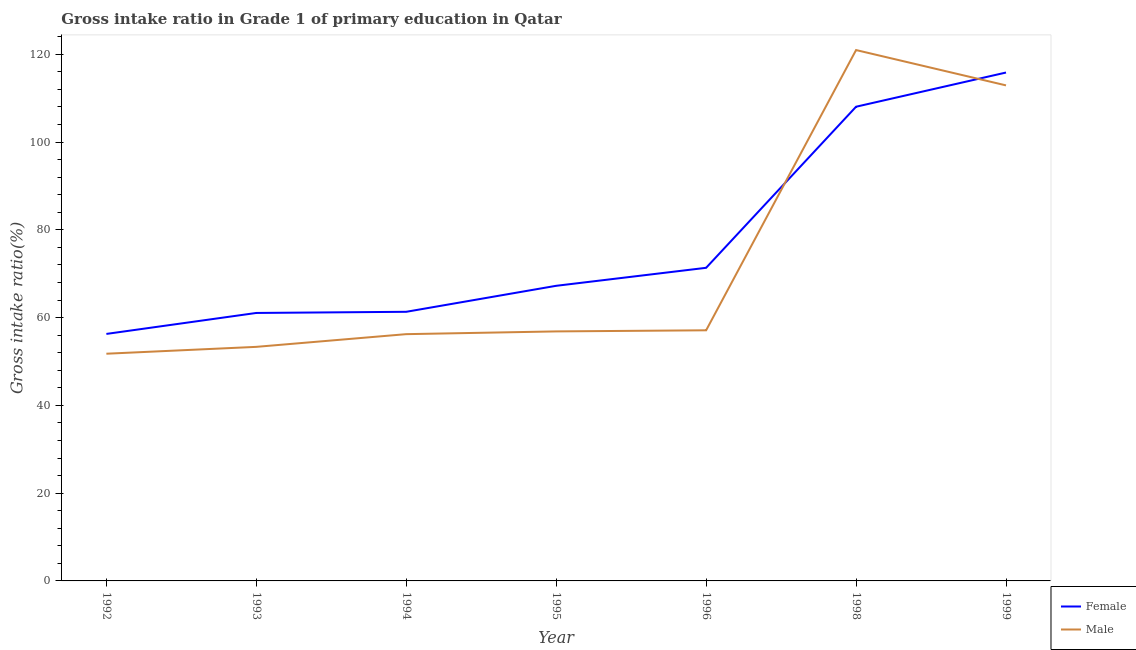How many different coloured lines are there?
Your answer should be very brief. 2. What is the gross intake ratio(female) in 1999?
Ensure brevity in your answer.  115.83. Across all years, what is the maximum gross intake ratio(male)?
Offer a terse response. 120.95. Across all years, what is the minimum gross intake ratio(male)?
Your response must be concise. 51.77. In which year was the gross intake ratio(female) minimum?
Your answer should be very brief. 1992. What is the total gross intake ratio(male) in the graph?
Offer a very short reply. 509.13. What is the difference between the gross intake ratio(female) in 1998 and that in 1999?
Provide a succinct answer. -7.79. What is the difference between the gross intake ratio(male) in 1996 and the gross intake ratio(female) in 1993?
Your response must be concise. -3.95. What is the average gross intake ratio(male) per year?
Keep it short and to the point. 72.73. In the year 1995, what is the difference between the gross intake ratio(female) and gross intake ratio(male)?
Provide a succinct answer. 10.39. What is the ratio of the gross intake ratio(male) in 1993 to that in 1999?
Offer a very short reply. 0.47. Is the gross intake ratio(female) in 1994 less than that in 1996?
Offer a very short reply. Yes. Is the difference between the gross intake ratio(male) in 1998 and 1999 greater than the difference between the gross intake ratio(female) in 1998 and 1999?
Provide a succinct answer. Yes. What is the difference between the highest and the second highest gross intake ratio(female)?
Give a very brief answer. 7.79. What is the difference between the highest and the lowest gross intake ratio(female)?
Offer a very short reply. 59.55. In how many years, is the gross intake ratio(male) greater than the average gross intake ratio(male) taken over all years?
Provide a short and direct response. 2. Is the gross intake ratio(male) strictly less than the gross intake ratio(female) over the years?
Provide a short and direct response. No. What is the difference between two consecutive major ticks on the Y-axis?
Offer a very short reply. 20. Does the graph contain any zero values?
Ensure brevity in your answer.  No. Does the graph contain grids?
Your answer should be compact. No. How many legend labels are there?
Your answer should be very brief. 2. How are the legend labels stacked?
Give a very brief answer. Vertical. What is the title of the graph?
Ensure brevity in your answer.  Gross intake ratio in Grade 1 of primary education in Qatar. Does "All education staff compensation" appear as one of the legend labels in the graph?
Keep it short and to the point. No. What is the label or title of the Y-axis?
Offer a terse response. Gross intake ratio(%). What is the Gross intake ratio(%) of Female in 1992?
Ensure brevity in your answer.  56.28. What is the Gross intake ratio(%) in Male in 1992?
Make the answer very short. 51.77. What is the Gross intake ratio(%) in Female in 1993?
Keep it short and to the point. 61.06. What is the Gross intake ratio(%) in Male in 1993?
Provide a short and direct response. 53.33. What is the Gross intake ratio(%) in Female in 1994?
Give a very brief answer. 61.32. What is the Gross intake ratio(%) in Male in 1994?
Ensure brevity in your answer.  56.23. What is the Gross intake ratio(%) in Female in 1995?
Provide a short and direct response. 67.24. What is the Gross intake ratio(%) of Male in 1995?
Your response must be concise. 56.85. What is the Gross intake ratio(%) in Female in 1996?
Provide a succinct answer. 71.34. What is the Gross intake ratio(%) in Male in 1996?
Make the answer very short. 57.1. What is the Gross intake ratio(%) of Female in 1998?
Your answer should be very brief. 108.04. What is the Gross intake ratio(%) in Male in 1998?
Provide a succinct answer. 120.95. What is the Gross intake ratio(%) of Female in 1999?
Your response must be concise. 115.83. What is the Gross intake ratio(%) of Male in 1999?
Make the answer very short. 112.9. Across all years, what is the maximum Gross intake ratio(%) in Female?
Ensure brevity in your answer.  115.83. Across all years, what is the maximum Gross intake ratio(%) of Male?
Keep it short and to the point. 120.95. Across all years, what is the minimum Gross intake ratio(%) of Female?
Ensure brevity in your answer.  56.28. Across all years, what is the minimum Gross intake ratio(%) of Male?
Offer a very short reply. 51.77. What is the total Gross intake ratio(%) of Female in the graph?
Your answer should be compact. 541.1. What is the total Gross intake ratio(%) of Male in the graph?
Give a very brief answer. 509.13. What is the difference between the Gross intake ratio(%) of Female in 1992 and that in 1993?
Your response must be concise. -4.78. What is the difference between the Gross intake ratio(%) in Male in 1992 and that in 1993?
Offer a terse response. -1.57. What is the difference between the Gross intake ratio(%) in Female in 1992 and that in 1994?
Your answer should be very brief. -5.04. What is the difference between the Gross intake ratio(%) of Male in 1992 and that in 1994?
Your answer should be very brief. -4.46. What is the difference between the Gross intake ratio(%) of Female in 1992 and that in 1995?
Your answer should be compact. -10.96. What is the difference between the Gross intake ratio(%) of Male in 1992 and that in 1995?
Give a very brief answer. -5.08. What is the difference between the Gross intake ratio(%) of Female in 1992 and that in 1996?
Provide a succinct answer. -15.06. What is the difference between the Gross intake ratio(%) of Male in 1992 and that in 1996?
Make the answer very short. -5.34. What is the difference between the Gross intake ratio(%) of Female in 1992 and that in 1998?
Offer a very short reply. -51.77. What is the difference between the Gross intake ratio(%) of Male in 1992 and that in 1998?
Ensure brevity in your answer.  -69.19. What is the difference between the Gross intake ratio(%) of Female in 1992 and that in 1999?
Ensure brevity in your answer.  -59.55. What is the difference between the Gross intake ratio(%) of Male in 1992 and that in 1999?
Ensure brevity in your answer.  -61.14. What is the difference between the Gross intake ratio(%) in Female in 1993 and that in 1994?
Provide a succinct answer. -0.26. What is the difference between the Gross intake ratio(%) of Male in 1993 and that in 1994?
Your answer should be compact. -2.89. What is the difference between the Gross intake ratio(%) in Female in 1993 and that in 1995?
Offer a very short reply. -6.19. What is the difference between the Gross intake ratio(%) of Male in 1993 and that in 1995?
Give a very brief answer. -3.52. What is the difference between the Gross intake ratio(%) in Female in 1993 and that in 1996?
Your response must be concise. -10.29. What is the difference between the Gross intake ratio(%) of Male in 1993 and that in 1996?
Your answer should be very brief. -3.77. What is the difference between the Gross intake ratio(%) of Female in 1993 and that in 1998?
Keep it short and to the point. -46.99. What is the difference between the Gross intake ratio(%) in Male in 1993 and that in 1998?
Your response must be concise. -67.62. What is the difference between the Gross intake ratio(%) in Female in 1993 and that in 1999?
Offer a very short reply. -54.78. What is the difference between the Gross intake ratio(%) of Male in 1993 and that in 1999?
Offer a terse response. -59.57. What is the difference between the Gross intake ratio(%) of Female in 1994 and that in 1995?
Offer a very short reply. -5.92. What is the difference between the Gross intake ratio(%) of Male in 1994 and that in 1995?
Make the answer very short. -0.62. What is the difference between the Gross intake ratio(%) in Female in 1994 and that in 1996?
Provide a succinct answer. -10.02. What is the difference between the Gross intake ratio(%) of Male in 1994 and that in 1996?
Make the answer very short. -0.88. What is the difference between the Gross intake ratio(%) of Female in 1994 and that in 1998?
Make the answer very short. -46.73. What is the difference between the Gross intake ratio(%) of Male in 1994 and that in 1998?
Give a very brief answer. -64.73. What is the difference between the Gross intake ratio(%) of Female in 1994 and that in 1999?
Offer a terse response. -54.51. What is the difference between the Gross intake ratio(%) in Male in 1994 and that in 1999?
Offer a very short reply. -56.68. What is the difference between the Gross intake ratio(%) in Female in 1995 and that in 1996?
Ensure brevity in your answer.  -4.1. What is the difference between the Gross intake ratio(%) in Male in 1995 and that in 1996?
Your response must be concise. -0.25. What is the difference between the Gross intake ratio(%) in Female in 1995 and that in 1998?
Give a very brief answer. -40.8. What is the difference between the Gross intake ratio(%) of Male in 1995 and that in 1998?
Provide a short and direct response. -64.1. What is the difference between the Gross intake ratio(%) in Female in 1995 and that in 1999?
Ensure brevity in your answer.  -48.59. What is the difference between the Gross intake ratio(%) in Male in 1995 and that in 1999?
Give a very brief answer. -56.06. What is the difference between the Gross intake ratio(%) in Female in 1996 and that in 1998?
Keep it short and to the point. -36.7. What is the difference between the Gross intake ratio(%) of Male in 1996 and that in 1998?
Make the answer very short. -63.85. What is the difference between the Gross intake ratio(%) of Female in 1996 and that in 1999?
Provide a succinct answer. -44.49. What is the difference between the Gross intake ratio(%) of Male in 1996 and that in 1999?
Offer a terse response. -55.8. What is the difference between the Gross intake ratio(%) of Female in 1998 and that in 1999?
Make the answer very short. -7.79. What is the difference between the Gross intake ratio(%) in Male in 1998 and that in 1999?
Give a very brief answer. 8.05. What is the difference between the Gross intake ratio(%) in Female in 1992 and the Gross intake ratio(%) in Male in 1993?
Make the answer very short. 2.95. What is the difference between the Gross intake ratio(%) of Female in 1992 and the Gross intake ratio(%) of Male in 1994?
Ensure brevity in your answer.  0.05. What is the difference between the Gross intake ratio(%) of Female in 1992 and the Gross intake ratio(%) of Male in 1995?
Provide a succinct answer. -0.57. What is the difference between the Gross intake ratio(%) of Female in 1992 and the Gross intake ratio(%) of Male in 1996?
Make the answer very short. -0.83. What is the difference between the Gross intake ratio(%) of Female in 1992 and the Gross intake ratio(%) of Male in 1998?
Ensure brevity in your answer.  -64.68. What is the difference between the Gross intake ratio(%) of Female in 1992 and the Gross intake ratio(%) of Male in 1999?
Your answer should be compact. -56.63. What is the difference between the Gross intake ratio(%) in Female in 1993 and the Gross intake ratio(%) in Male in 1994?
Keep it short and to the point. 4.83. What is the difference between the Gross intake ratio(%) in Female in 1993 and the Gross intake ratio(%) in Male in 1995?
Keep it short and to the point. 4.21. What is the difference between the Gross intake ratio(%) of Female in 1993 and the Gross intake ratio(%) of Male in 1996?
Your answer should be compact. 3.95. What is the difference between the Gross intake ratio(%) in Female in 1993 and the Gross intake ratio(%) in Male in 1998?
Ensure brevity in your answer.  -59.9. What is the difference between the Gross intake ratio(%) in Female in 1993 and the Gross intake ratio(%) in Male in 1999?
Keep it short and to the point. -51.85. What is the difference between the Gross intake ratio(%) of Female in 1994 and the Gross intake ratio(%) of Male in 1995?
Your response must be concise. 4.47. What is the difference between the Gross intake ratio(%) in Female in 1994 and the Gross intake ratio(%) in Male in 1996?
Offer a terse response. 4.21. What is the difference between the Gross intake ratio(%) in Female in 1994 and the Gross intake ratio(%) in Male in 1998?
Your response must be concise. -59.64. What is the difference between the Gross intake ratio(%) of Female in 1994 and the Gross intake ratio(%) of Male in 1999?
Your answer should be compact. -51.59. What is the difference between the Gross intake ratio(%) of Female in 1995 and the Gross intake ratio(%) of Male in 1996?
Give a very brief answer. 10.14. What is the difference between the Gross intake ratio(%) in Female in 1995 and the Gross intake ratio(%) in Male in 1998?
Give a very brief answer. -53.71. What is the difference between the Gross intake ratio(%) of Female in 1995 and the Gross intake ratio(%) of Male in 1999?
Give a very brief answer. -45.66. What is the difference between the Gross intake ratio(%) of Female in 1996 and the Gross intake ratio(%) of Male in 1998?
Offer a very short reply. -49.61. What is the difference between the Gross intake ratio(%) in Female in 1996 and the Gross intake ratio(%) in Male in 1999?
Your response must be concise. -41.56. What is the difference between the Gross intake ratio(%) of Female in 1998 and the Gross intake ratio(%) of Male in 1999?
Offer a very short reply. -4.86. What is the average Gross intake ratio(%) in Female per year?
Your response must be concise. 77.3. What is the average Gross intake ratio(%) in Male per year?
Provide a short and direct response. 72.73. In the year 1992, what is the difference between the Gross intake ratio(%) of Female and Gross intake ratio(%) of Male?
Provide a short and direct response. 4.51. In the year 1993, what is the difference between the Gross intake ratio(%) in Female and Gross intake ratio(%) in Male?
Keep it short and to the point. 7.72. In the year 1994, what is the difference between the Gross intake ratio(%) in Female and Gross intake ratio(%) in Male?
Provide a short and direct response. 5.09. In the year 1995, what is the difference between the Gross intake ratio(%) in Female and Gross intake ratio(%) in Male?
Your answer should be compact. 10.39. In the year 1996, what is the difference between the Gross intake ratio(%) in Female and Gross intake ratio(%) in Male?
Keep it short and to the point. 14.24. In the year 1998, what is the difference between the Gross intake ratio(%) of Female and Gross intake ratio(%) of Male?
Your response must be concise. -12.91. In the year 1999, what is the difference between the Gross intake ratio(%) in Female and Gross intake ratio(%) in Male?
Your answer should be compact. 2.93. What is the ratio of the Gross intake ratio(%) in Female in 1992 to that in 1993?
Your answer should be very brief. 0.92. What is the ratio of the Gross intake ratio(%) of Male in 1992 to that in 1993?
Keep it short and to the point. 0.97. What is the ratio of the Gross intake ratio(%) of Female in 1992 to that in 1994?
Your response must be concise. 0.92. What is the ratio of the Gross intake ratio(%) in Male in 1992 to that in 1994?
Your answer should be very brief. 0.92. What is the ratio of the Gross intake ratio(%) of Female in 1992 to that in 1995?
Your response must be concise. 0.84. What is the ratio of the Gross intake ratio(%) of Male in 1992 to that in 1995?
Keep it short and to the point. 0.91. What is the ratio of the Gross intake ratio(%) of Female in 1992 to that in 1996?
Make the answer very short. 0.79. What is the ratio of the Gross intake ratio(%) in Male in 1992 to that in 1996?
Your answer should be compact. 0.91. What is the ratio of the Gross intake ratio(%) in Female in 1992 to that in 1998?
Your response must be concise. 0.52. What is the ratio of the Gross intake ratio(%) in Male in 1992 to that in 1998?
Ensure brevity in your answer.  0.43. What is the ratio of the Gross intake ratio(%) in Female in 1992 to that in 1999?
Give a very brief answer. 0.49. What is the ratio of the Gross intake ratio(%) in Male in 1992 to that in 1999?
Your response must be concise. 0.46. What is the ratio of the Gross intake ratio(%) in Female in 1993 to that in 1994?
Offer a very short reply. 1. What is the ratio of the Gross intake ratio(%) of Male in 1993 to that in 1994?
Offer a terse response. 0.95. What is the ratio of the Gross intake ratio(%) in Female in 1993 to that in 1995?
Your answer should be compact. 0.91. What is the ratio of the Gross intake ratio(%) in Male in 1993 to that in 1995?
Offer a terse response. 0.94. What is the ratio of the Gross intake ratio(%) in Female in 1993 to that in 1996?
Provide a short and direct response. 0.86. What is the ratio of the Gross intake ratio(%) of Male in 1993 to that in 1996?
Offer a terse response. 0.93. What is the ratio of the Gross intake ratio(%) in Female in 1993 to that in 1998?
Keep it short and to the point. 0.57. What is the ratio of the Gross intake ratio(%) in Male in 1993 to that in 1998?
Provide a succinct answer. 0.44. What is the ratio of the Gross intake ratio(%) in Female in 1993 to that in 1999?
Give a very brief answer. 0.53. What is the ratio of the Gross intake ratio(%) of Male in 1993 to that in 1999?
Keep it short and to the point. 0.47. What is the ratio of the Gross intake ratio(%) of Female in 1994 to that in 1995?
Ensure brevity in your answer.  0.91. What is the ratio of the Gross intake ratio(%) of Male in 1994 to that in 1995?
Offer a terse response. 0.99. What is the ratio of the Gross intake ratio(%) of Female in 1994 to that in 1996?
Give a very brief answer. 0.86. What is the ratio of the Gross intake ratio(%) in Male in 1994 to that in 1996?
Ensure brevity in your answer.  0.98. What is the ratio of the Gross intake ratio(%) of Female in 1994 to that in 1998?
Your response must be concise. 0.57. What is the ratio of the Gross intake ratio(%) of Male in 1994 to that in 1998?
Keep it short and to the point. 0.46. What is the ratio of the Gross intake ratio(%) in Female in 1994 to that in 1999?
Your response must be concise. 0.53. What is the ratio of the Gross intake ratio(%) in Male in 1994 to that in 1999?
Your answer should be compact. 0.5. What is the ratio of the Gross intake ratio(%) in Female in 1995 to that in 1996?
Ensure brevity in your answer.  0.94. What is the ratio of the Gross intake ratio(%) in Male in 1995 to that in 1996?
Provide a succinct answer. 1. What is the ratio of the Gross intake ratio(%) in Female in 1995 to that in 1998?
Keep it short and to the point. 0.62. What is the ratio of the Gross intake ratio(%) in Male in 1995 to that in 1998?
Give a very brief answer. 0.47. What is the ratio of the Gross intake ratio(%) of Female in 1995 to that in 1999?
Your answer should be very brief. 0.58. What is the ratio of the Gross intake ratio(%) in Male in 1995 to that in 1999?
Make the answer very short. 0.5. What is the ratio of the Gross intake ratio(%) of Female in 1996 to that in 1998?
Make the answer very short. 0.66. What is the ratio of the Gross intake ratio(%) of Male in 1996 to that in 1998?
Your answer should be compact. 0.47. What is the ratio of the Gross intake ratio(%) of Female in 1996 to that in 1999?
Your answer should be very brief. 0.62. What is the ratio of the Gross intake ratio(%) in Male in 1996 to that in 1999?
Offer a very short reply. 0.51. What is the ratio of the Gross intake ratio(%) of Female in 1998 to that in 1999?
Your answer should be very brief. 0.93. What is the ratio of the Gross intake ratio(%) of Male in 1998 to that in 1999?
Your response must be concise. 1.07. What is the difference between the highest and the second highest Gross intake ratio(%) in Female?
Your answer should be compact. 7.79. What is the difference between the highest and the second highest Gross intake ratio(%) of Male?
Offer a very short reply. 8.05. What is the difference between the highest and the lowest Gross intake ratio(%) of Female?
Give a very brief answer. 59.55. What is the difference between the highest and the lowest Gross intake ratio(%) of Male?
Your answer should be very brief. 69.19. 